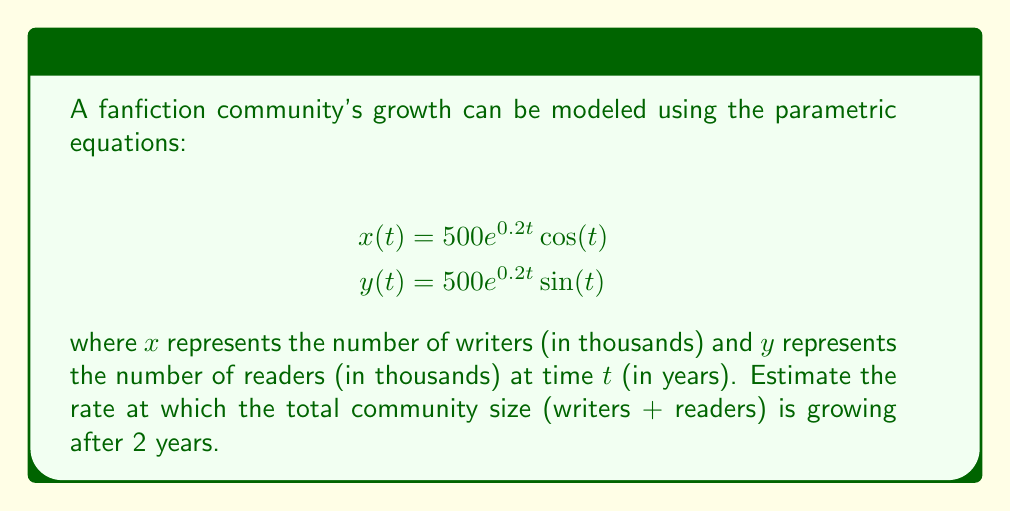Help me with this question. To solve this problem, we'll follow these steps:

1) The total community size $S(t)$ is given by:
   $$S(t) = x(t) + y(t)$$

2) We need to find $\frac{dS}{dt}$ at $t=2$. Using the chain rule:
   $$\frac{dS}{dt} = \frac{dx}{dt} + \frac{dy}{dt}$$

3) Let's calculate $\frac{dx}{dt}$:
   $$\frac{dx}{dt} = 500e^{0.2t}(0.2\cos(t) - \sin(t))$$

4) Similarly, for $\frac{dy}{dt}$:
   $$\frac{dy}{dt} = 500e^{0.2t}(0.2\sin(t) + \cos(t))$$

5) Adding these together:
   $$\frac{dS}{dt} = 500e^{0.2t}(0.2\cos(t) - \sin(t)) + 500e^{0.2t}(0.2\sin(t) + \cos(t))$$
   $$= 500e^{0.2t}(0.2\cos(t) - \sin(t) + 0.2\sin(t) + \cos(t))$$
   $$= 500e^{0.2t}(0.2(\cos(t) + \sin(t)) + (\cos(t) - \sin(t)))$$

6) Evaluating at $t=2$:
   $$\frac{dS}{dt}|_{t=2} = 500e^{0.4}(0.2(\cos(2) + \sin(2)) + (\cos(2) - \sin(2)))$$
   $$\approx 500 \cdot 1.4918 \cdot (0.2(-0.4161 + 0.9093) + (-0.4161 - 0.9093))$$
   $$\approx 745.9 \cdot (0.2(0.4932) - 1.3254)$$
   $$\approx 745.9 \cdot (-1.2268)$$
   $$\approx -915.1$$
Answer: -915.1 thousand per year 